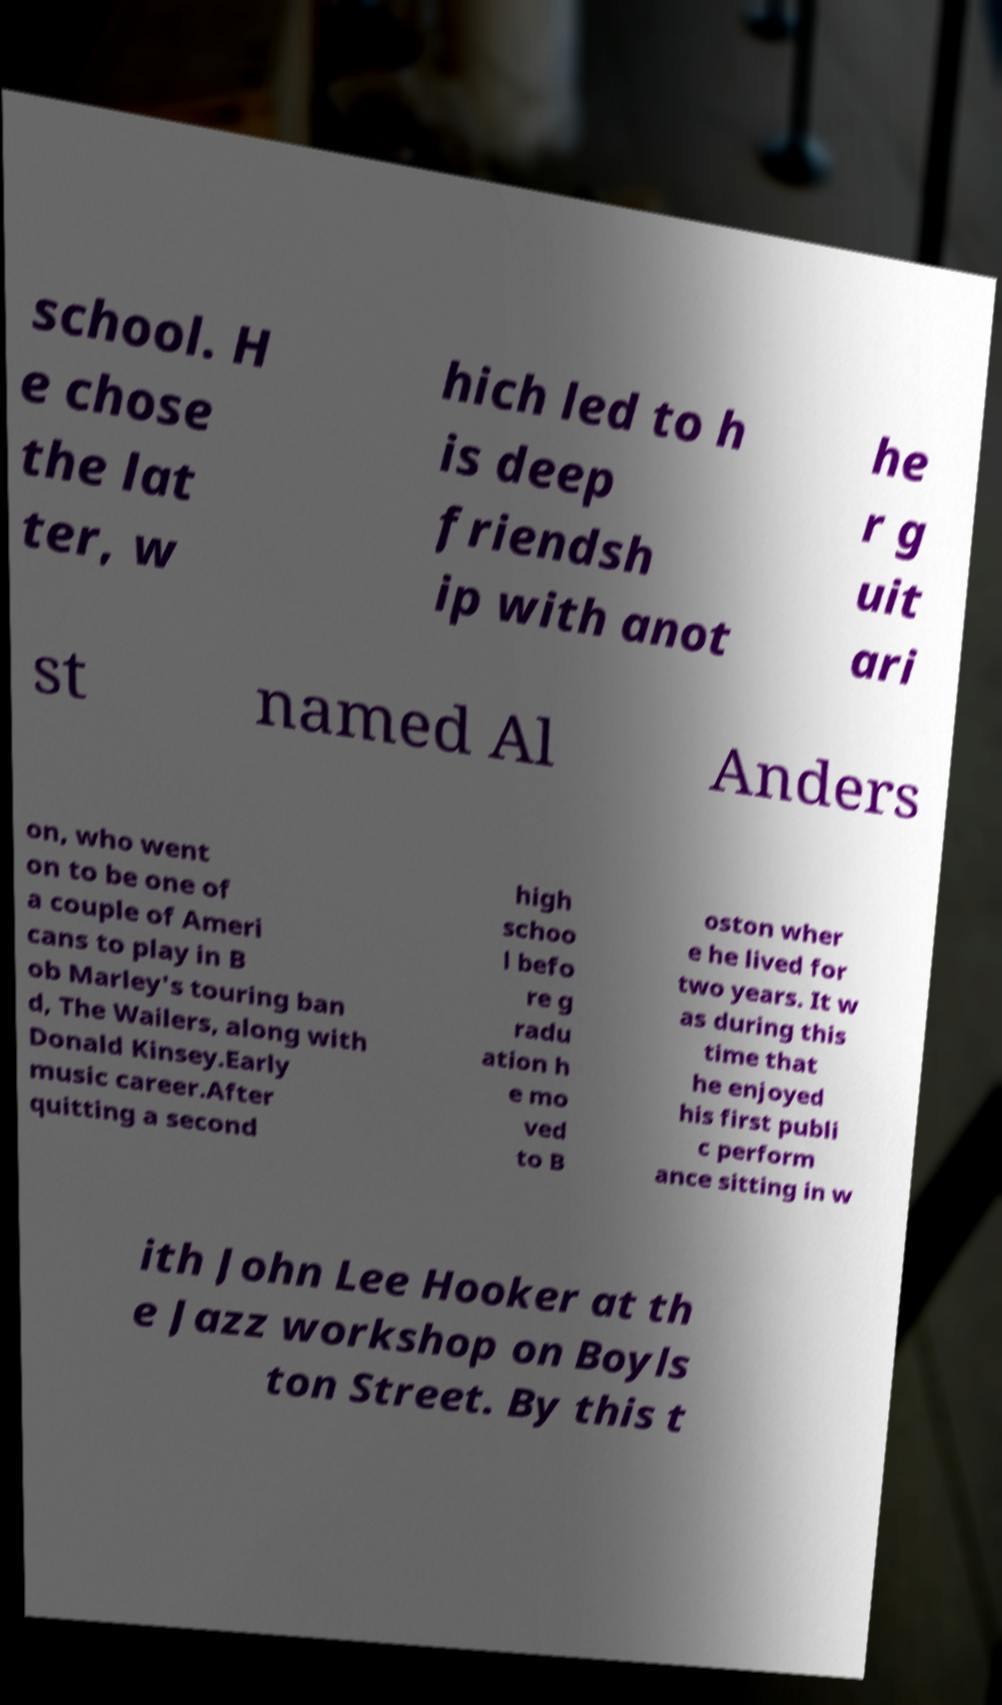What messages or text are displayed in this image? I need them in a readable, typed format. school. H e chose the lat ter, w hich led to h is deep friendsh ip with anot he r g uit ari st named Al Anders on, who went on to be one of a couple of Ameri cans to play in B ob Marley's touring ban d, The Wailers, along with Donald Kinsey.Early music career.After quitting a second high schoo l befo re g radu ation h e mo ved to B oston wher e he lived for two years. It w as during this time that he enjoyed his first publi c perform ance sitting in w ith John Lee Hooker at th e Jazz workshop on Boyls ton Street. By this t 